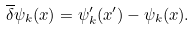Convert formula to latex. <formula><loc_0><loc_0><loc_500><loc_500>\overline { \delta } \psi _ { k } ( x ) = \psi _ { k } ^ { \prime } ( x ^ { \prime } ) - \psi _ { k } ( x ) .</formula> 